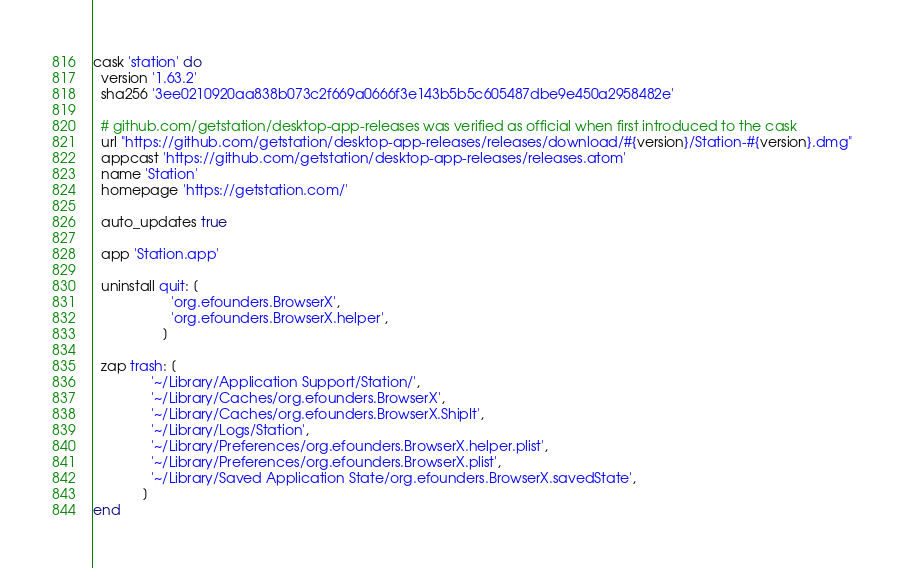Convert code to text. <code><loc_0><loc_0><loc_500><loc_500><_Ruby_>cask 'station' do
  version '1.63.2'
  sha256 '3ee0210920aa838b073c2f669a0666f3e143b5b5c605487dbe9e450a2958482e'

  # github.com/getstation/desktop-app-releases was verified as official when first introduced to the cask
  url "https://github.com/getstation/desktop-app-releases/releases/download/#{version}/Station-#{version}.dmg"
  appcast 'https://github.com/getstation/desktop-app-releases/releases.atom'
  name 'Station'
  homepage 'https://getstation.com/'

  auto_updates true

  app 'Station.app'

  uninstall quit: [
                    'org.efounders.BrowserX',
                    'org.efounders.BrowserX.helper',
                  ]

  zap trash: [
               '~/Library/Application Support/Station/',
               '~/Library/Caches/org.efounders.BrowserX',
               '~/Library/Caches/org.efounders.BrowserX.ShipIt',
               '~/Library/Logs/Station',
               '~/Library/Preferences/org.efounders.BrowserX.helper.plist',
               '~/Library/Preferences/org.efounders.BrowserX.plist',
               '~/Library/Saved Application State/org.efounders.BrowserX.savedState',
             ]
end
</code> 